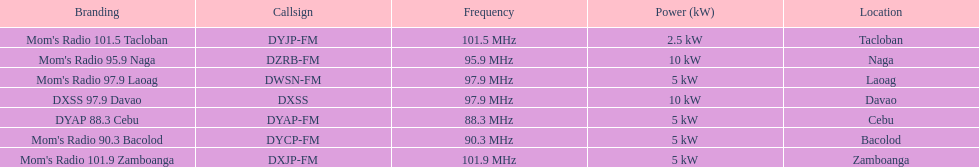What is the last location on this chart? Davao. 